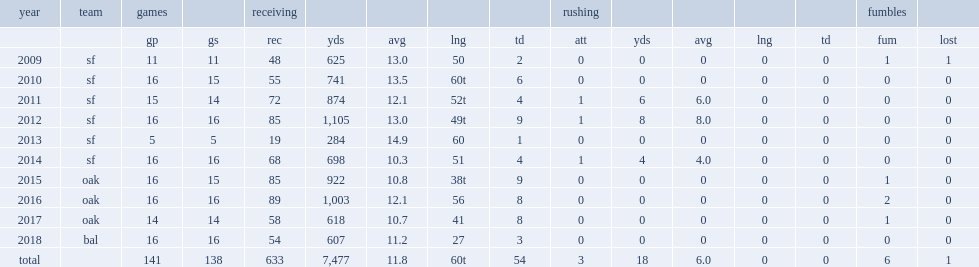How many receptions did crabtree get in 2015? 85.0. 